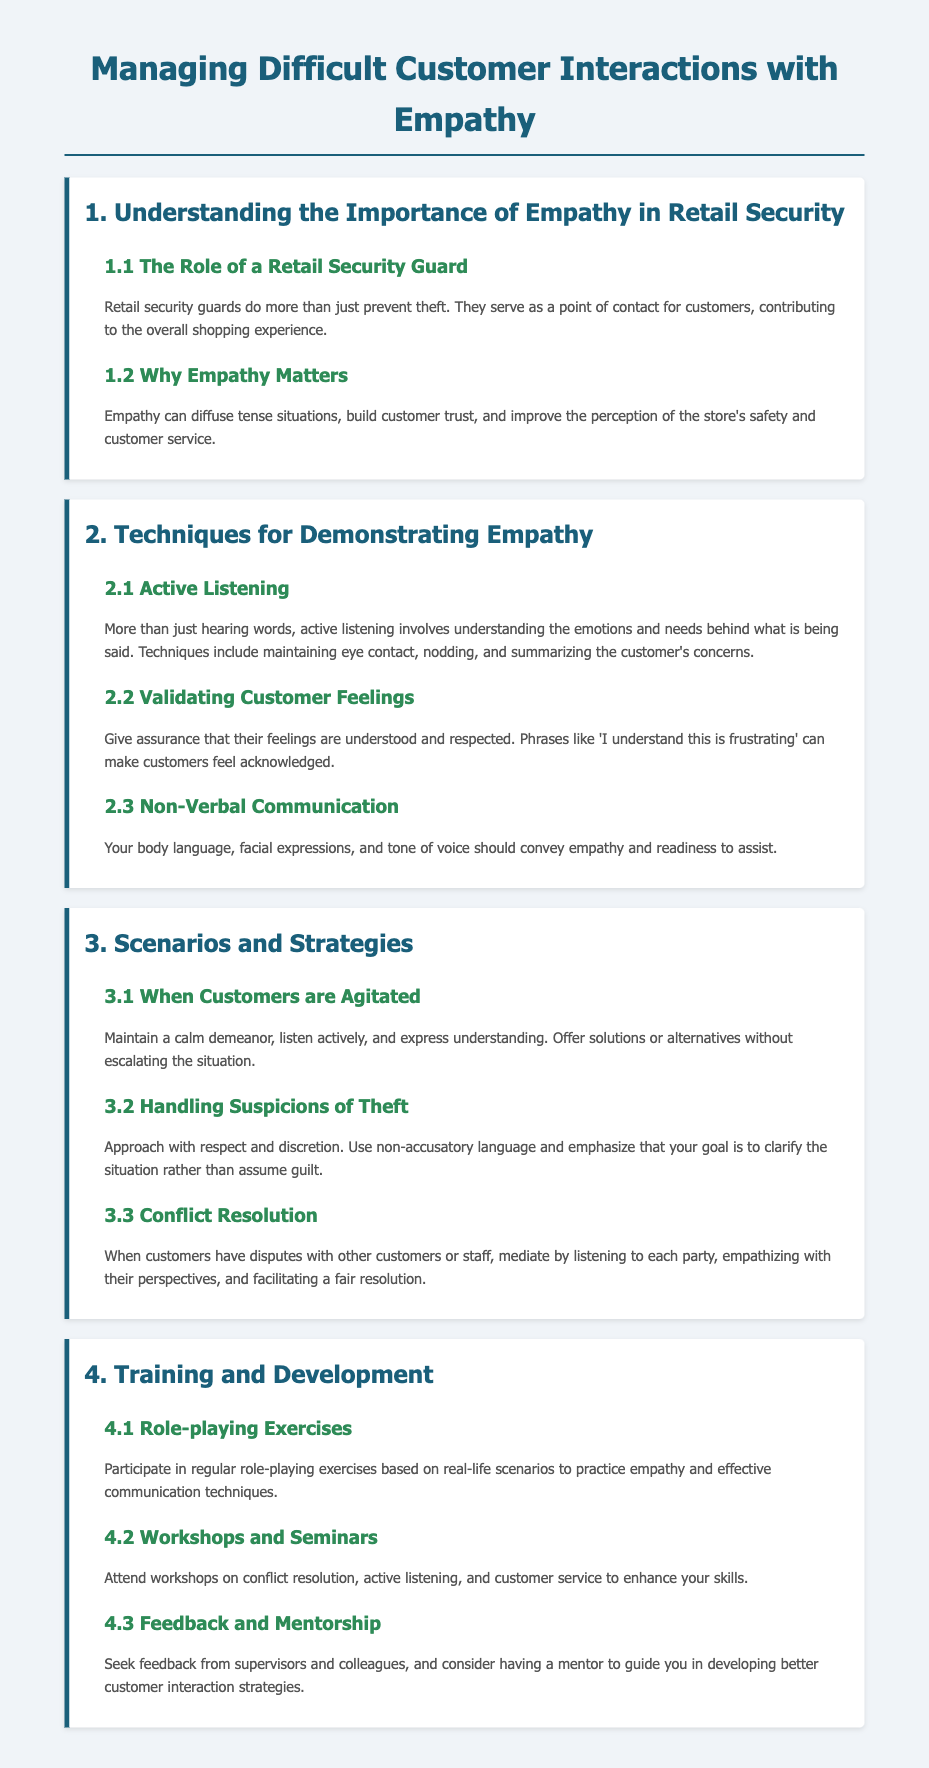what is the title of the document? The title of the document is the heading found at the top of the rendered page.
Answer: Managing Difficult Customer Interactions with Empathy what is the main role of a retail security guard? The role of a retail security guard is mentioned in section 1.1, emphasizing their contribution to customer experience.
Answer: A point of contact for customers why is empathy important in retail security? The significance of empathy is discussed in section 1.2, highlighting its positive effects.
Answer: Diffuse tense situations what technique is used for understanding emotions? The document discusses various techniques, and one specifically focuses on deeply engaging with customer communication.
Answer: Active Listening how should a security guard approach a situation of suspected theft? Section 3.2 outlines the recommended approach when dealing with suspicions of theft, mentioning a key aspect of communication.
Answer: Use non-accusatory language what is one method to practice empathy mentioned in the training section? The training section includes various practices, and one method emphasizes simulating real-life situations.
Answer: Role-playing Exercises how can a security guard validate customer feelings? The document suggests phrases that can be used to acknowledge customer feelings in section 2.2.
Answer: "I understand this is frustrating" what should be done when customers are agitated? Section 3.1 outlines a strategy for dealing with agitated customers that emphasizes demeanor.
Answer: Maintain a calm demeanor 